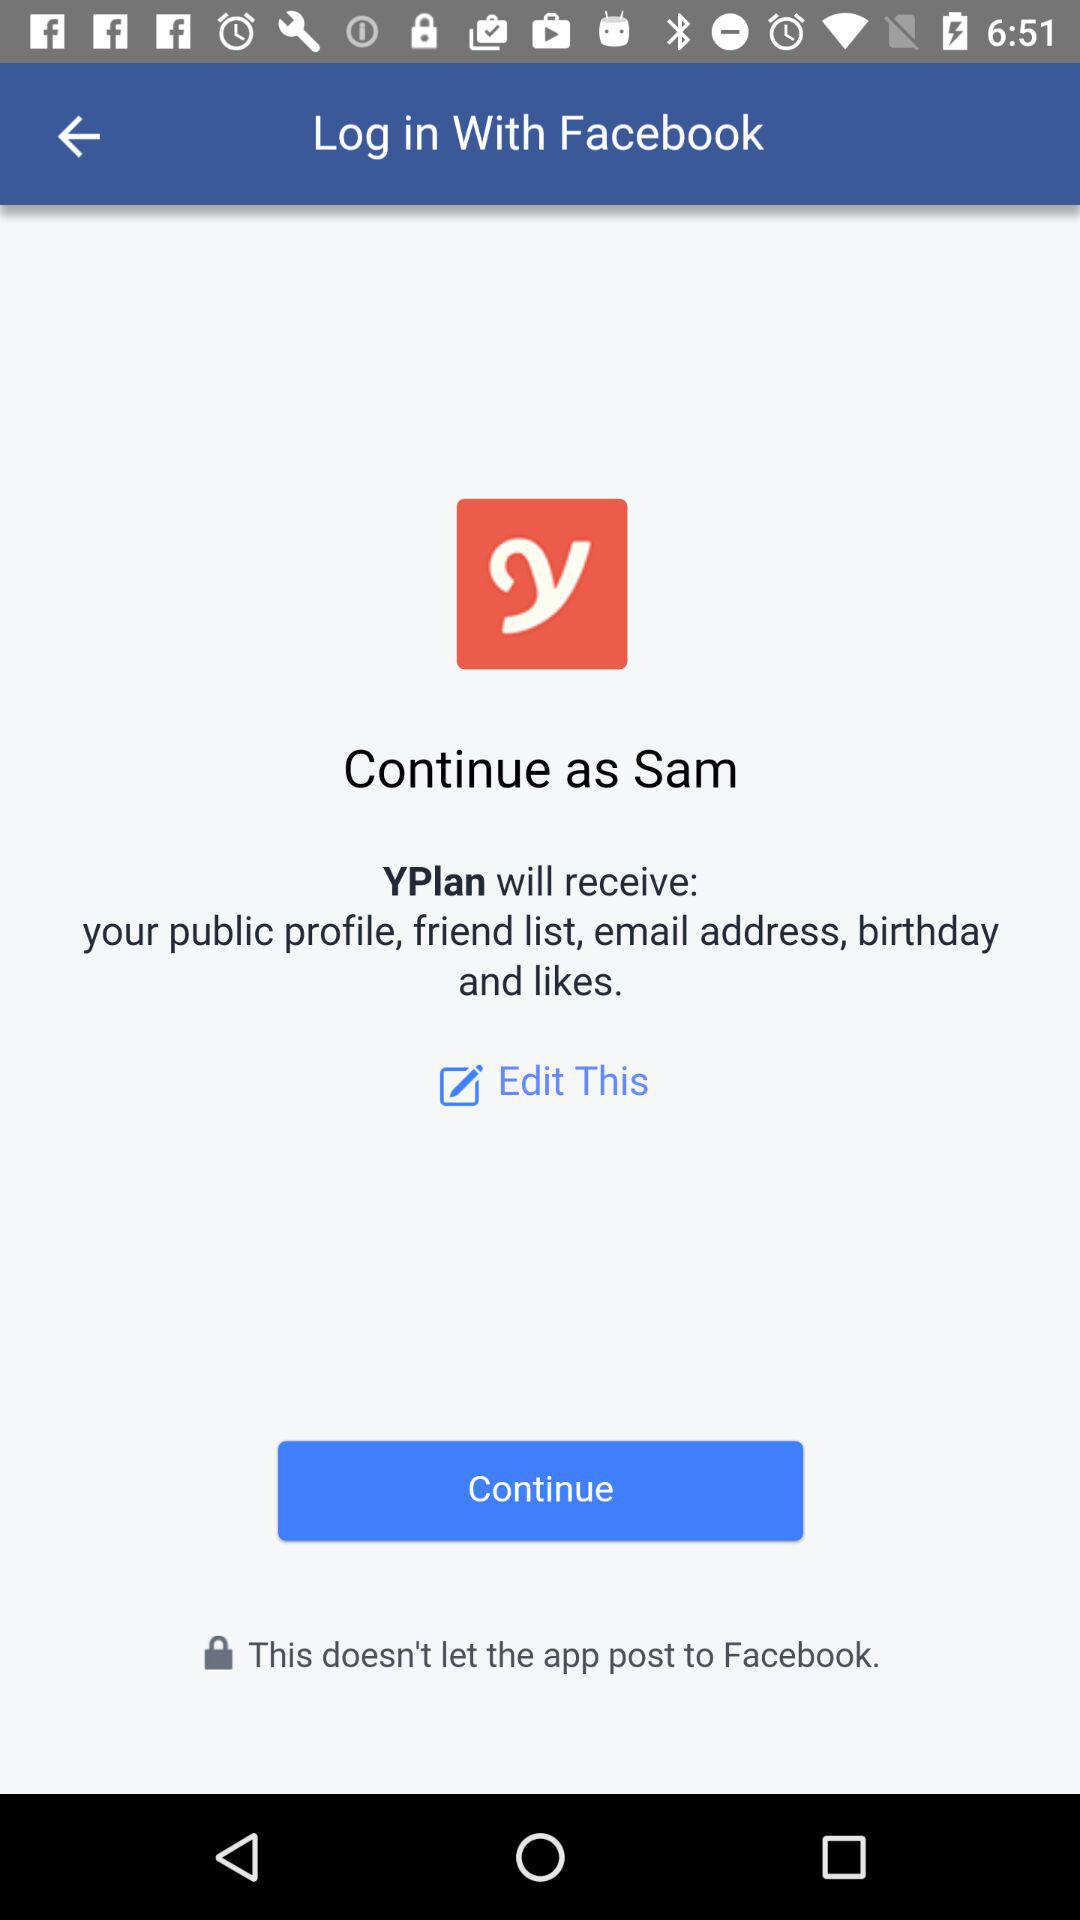What application is asking for permission? The application asking for permission is "YPlan". 